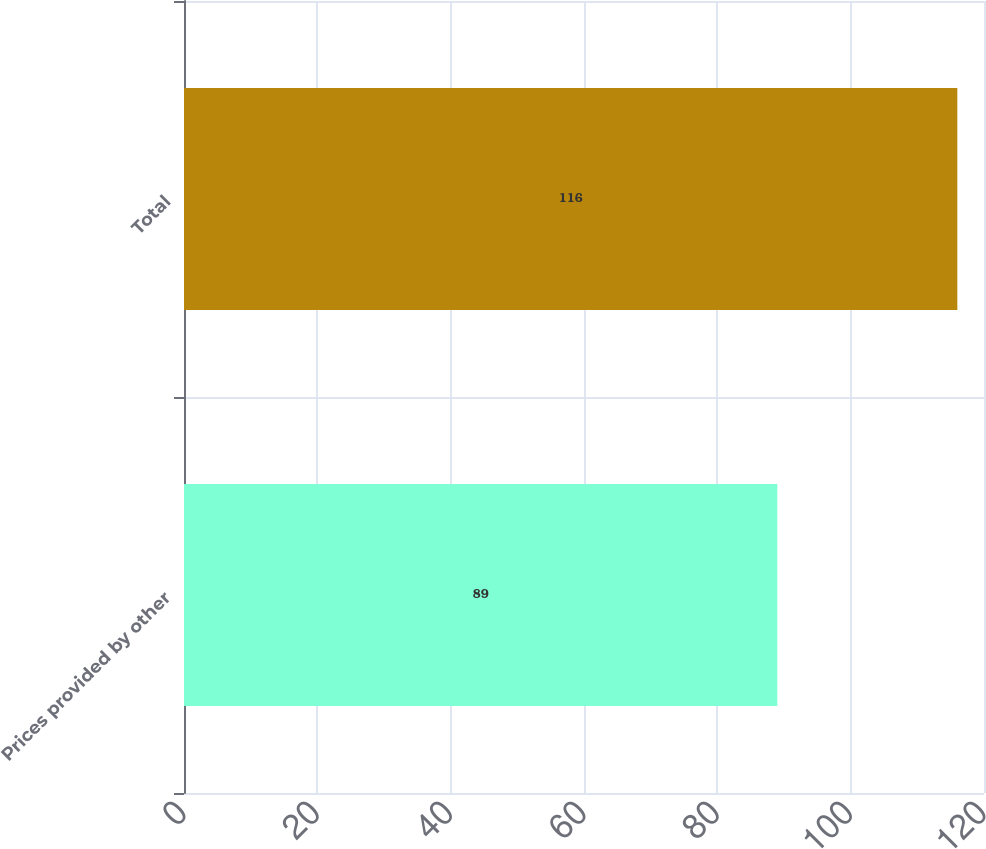Convert chart. <chart><loc_0><loc_0><loc_500><loc_500><bar_chart><fcel>Prices provided by other<fcel>Total<nl><fcel>89<fcel>116<nl></chart> 